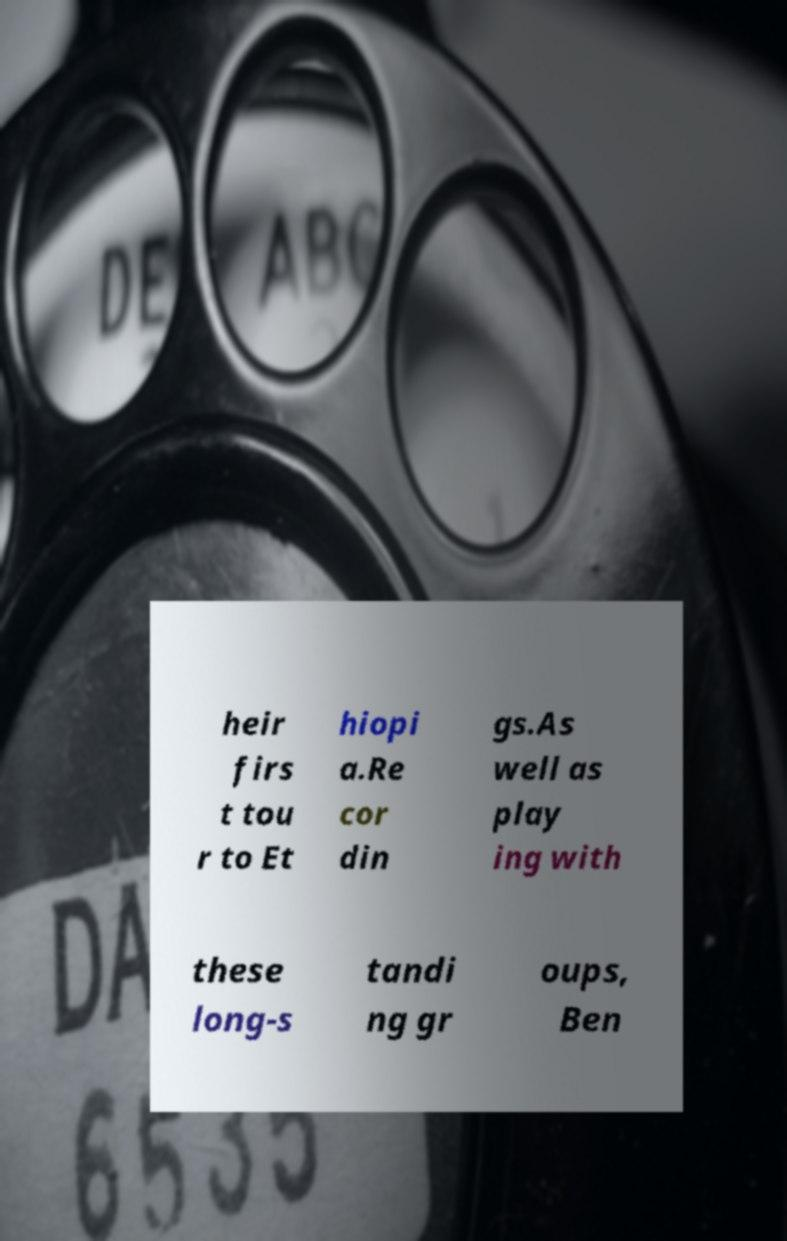Please read and relay the text visible in this image. What does it say? heir firs t tou r to Et hiopi a.Re cor din gs.As well as play ing with these long-s tandi ng gr oups, Ben 